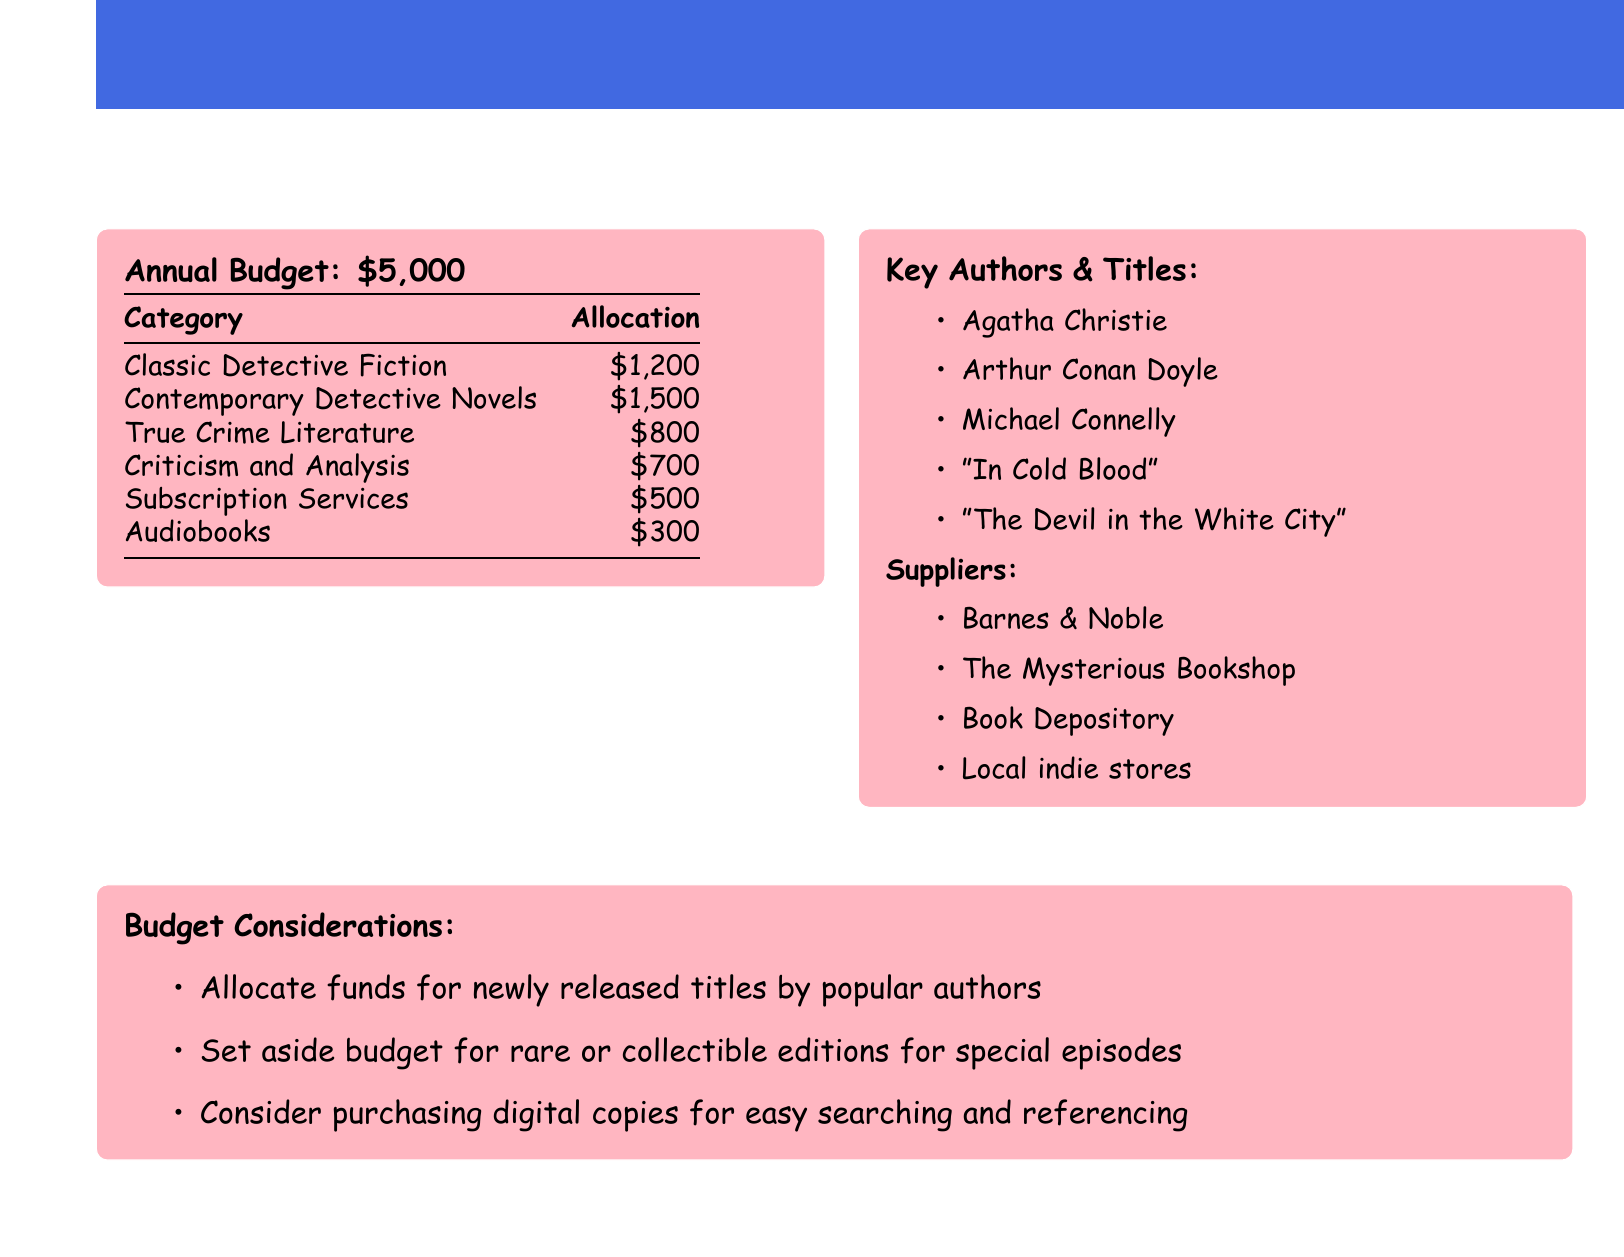What is the total annual budget? The annual budget is listed at the top of the document.
Answer: $5,000 How much is allocated for Classic Detective Fiction? The allocation for Classic Detective Fiction is specified in the budget table.
Answer: $1,200 Which category has the highest allocation? The highest allocation can be found by comparing the values in the budget table.
Answer: Contemporary Detective Novels Name one key author mentioned in the document. The document lists several key authors in the specified section.
Answer: Agatha Christie What percentage of the budget is allocated to True Crime Literature? The percentage can be calculated by dividing the allocation by the total budget and multiplying by 100.
Answer: 16% Which supplier is mentioned in the document? The document includes a list of suppliers for purchasing literature.
Answer: Barnes & Noble What is one budget consideration noted? The document outlines specific budget considerations that need to be taken into account.
Answer: Allocate funds for newly released titles How much is budgeted for subscription services? The budget table specifies the allocation for subscription services.
Answer: $500 